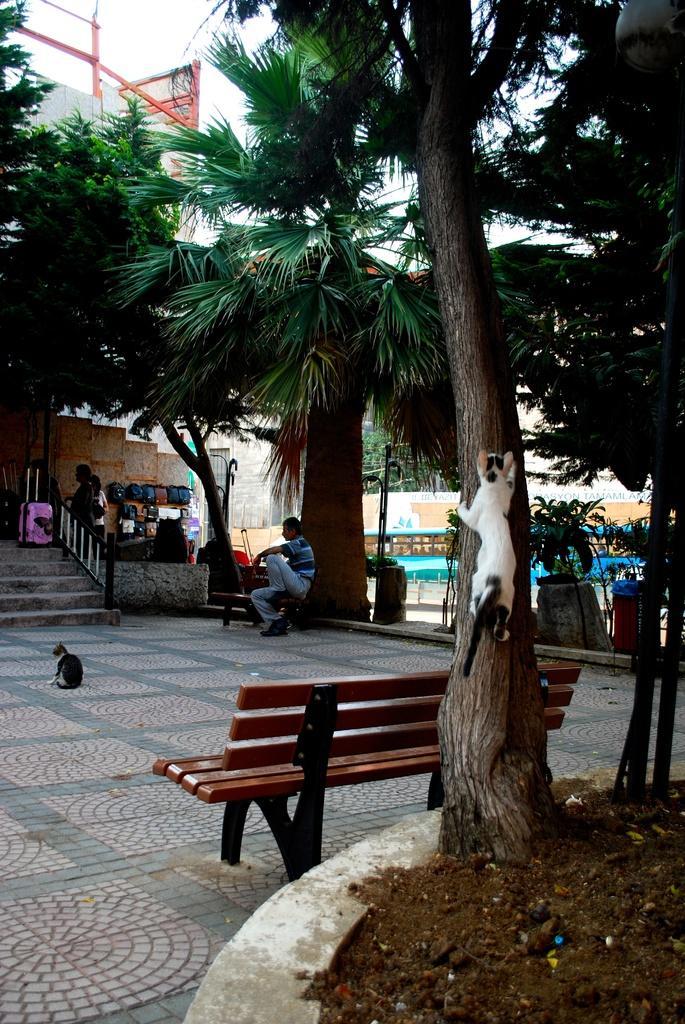Describe this image in one or two sentences. In this image i can see a cat climbing the tree at the back ground i can see a bench, a person sitting, stairs and a building. 